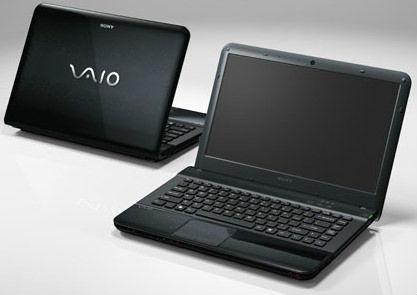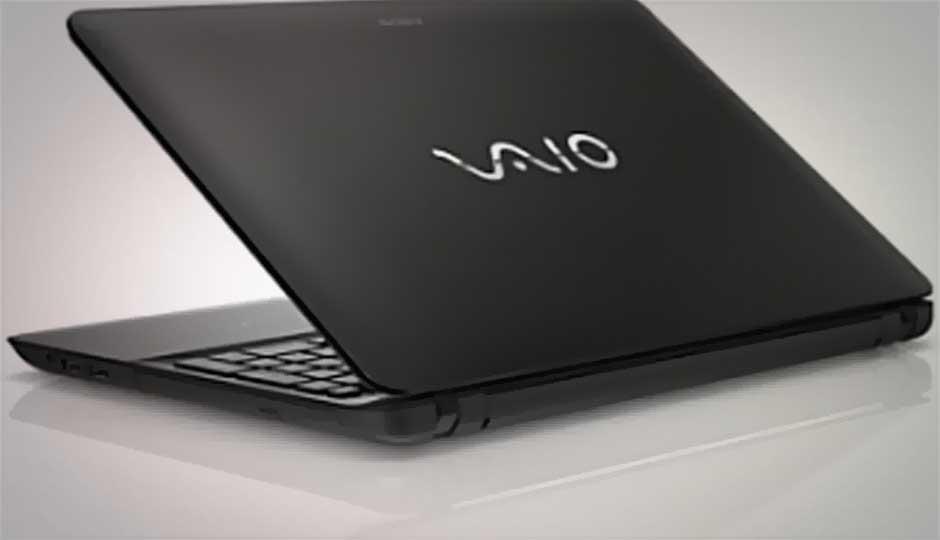The first image is the image on the left, the second image is the image on the right. Given the left and right images, does the statement "There are three laptops, and every visible screen is black." hold true? Answer yes or no. Yes. The first image is the image on the left, the second image is the image on the right. Evaluate the accuracy of this statement regarding the images: "There is exactly two lap tops in the left image.". Is it true? Answer yes or no. Yes. 